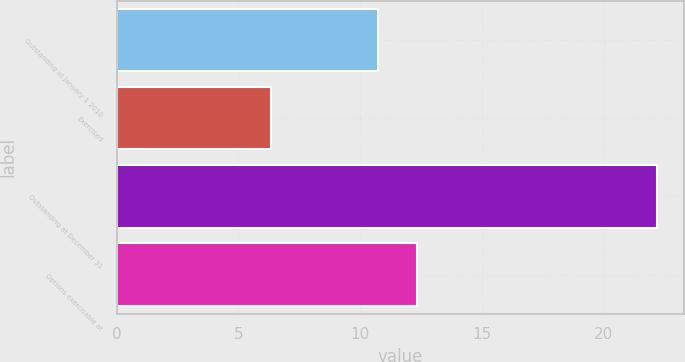<chart> <loc_0><loc_0><loc_500><loc_500><bar_chart><fcel>Outstanding at January 1 2010<fcel>Exercised<fcel>Outstanding at December 31<fcel>Options exercisable at<nl><fcel>10.74<fcel>6.36<fcel>22.21<fcel>12.35<nl></chart> 